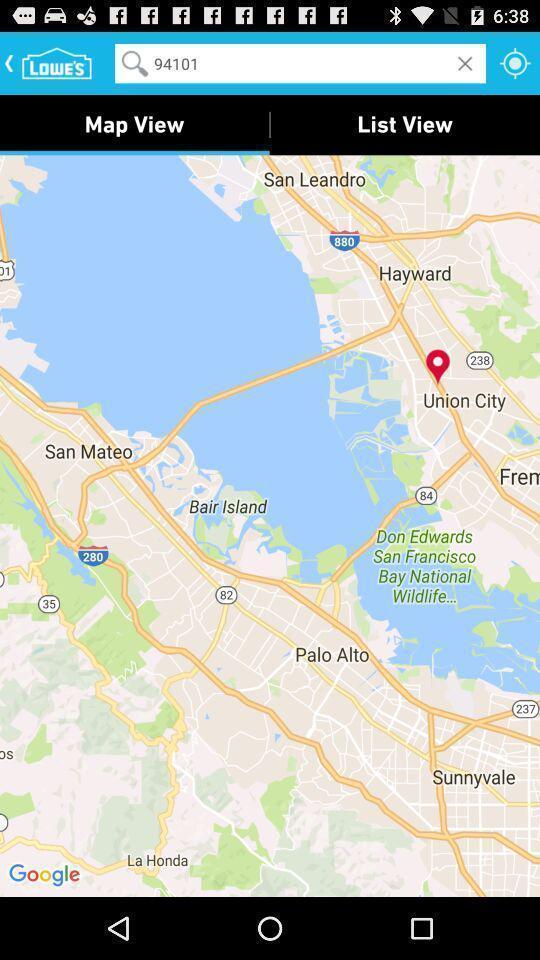Give me a narrative description of this picture. Screen displaying the map view image. 